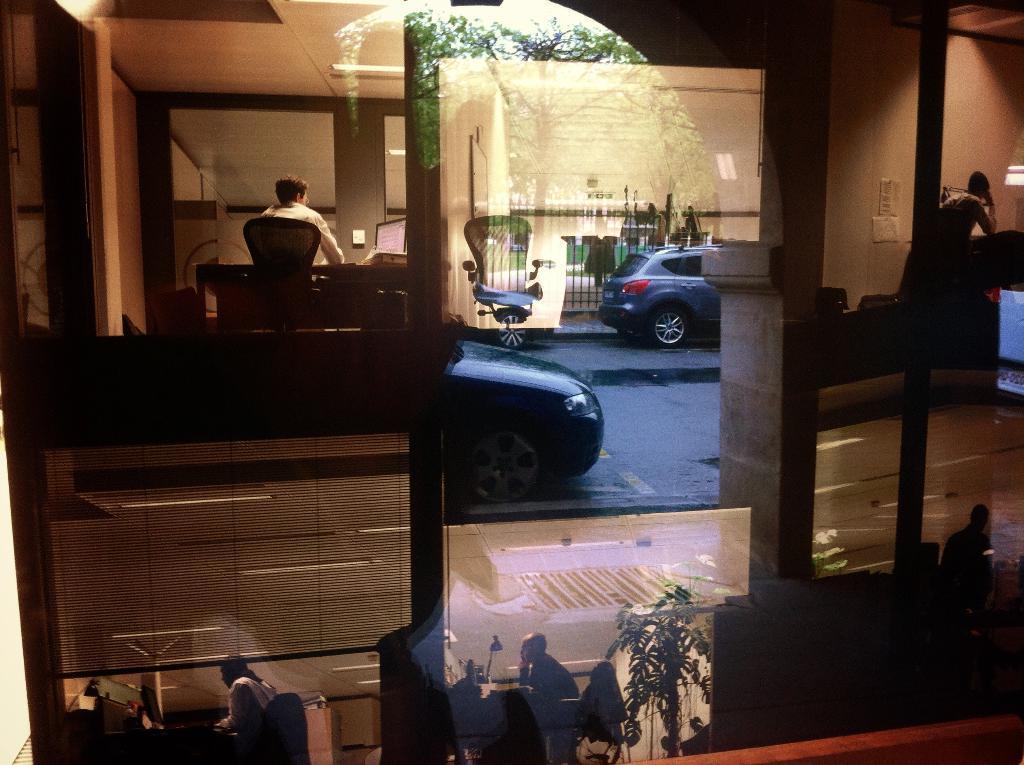Could you give a brief overview of what you see in this image? This picture consists of two vehicles visible on road, there is a fence, tree, visible in the middle , at the bottom there are two persons sitting on chair and plant and on the right side there is a person, wall, screen , pole, another person, on the left side a person sitting on the chair and a wall visible. 